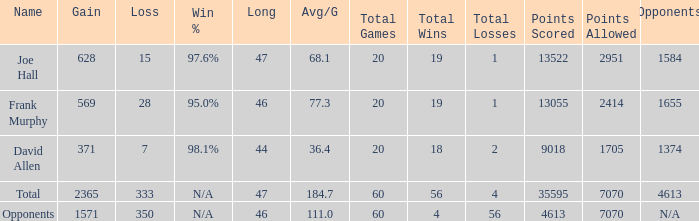Which Avg/G is the lowest one that has a Long smaller than 47, and a Name of frank murphy, and a Gain smaller than 569? None. 